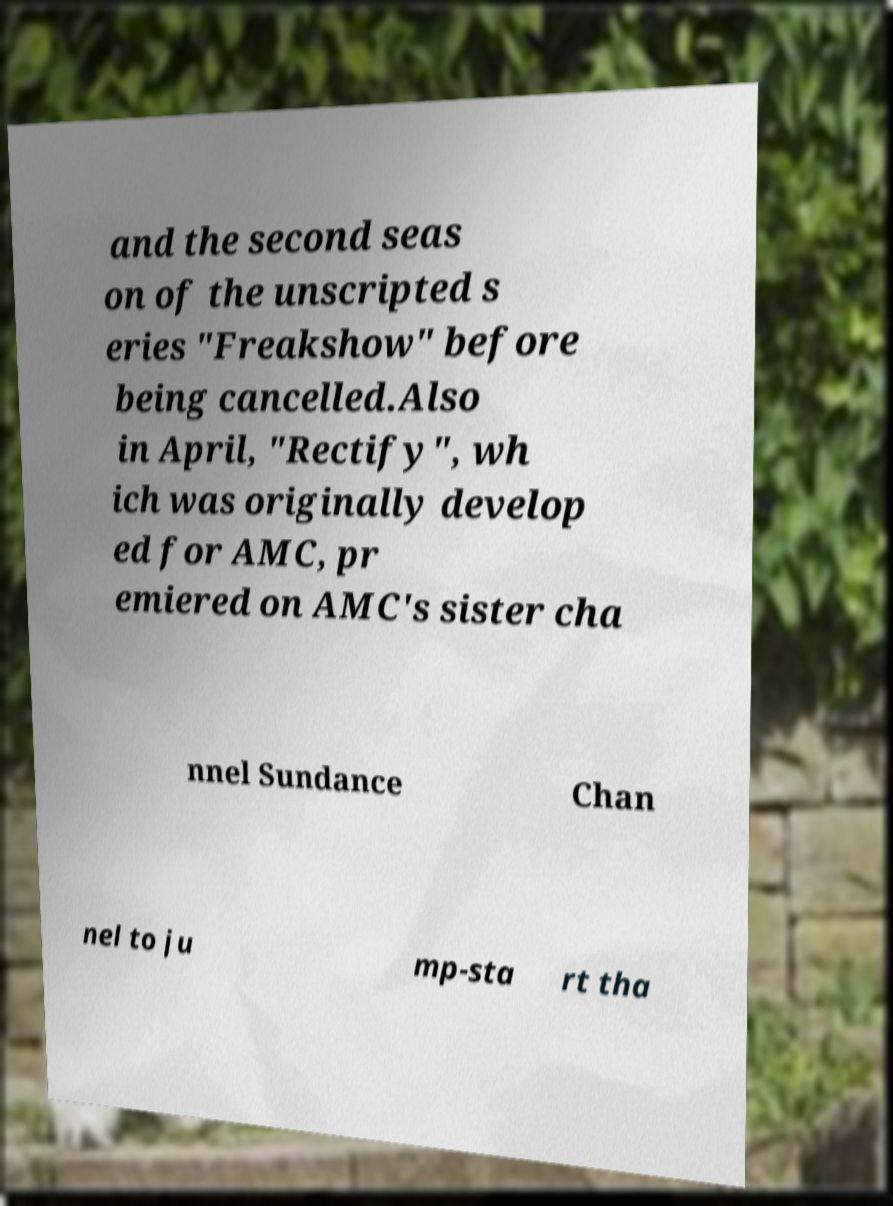There's text embedded in this image that I need extracted. Can you transcribe it verbatim? and the second seas on of the unscripted s eries "Freakshow" before being cancelled.Also in April, "Rectify", wh ich was originally develop ed for AMC, pr emiered on AMC's sister cha nnel Sundance Chan nel to ju mp-sta rt tha 